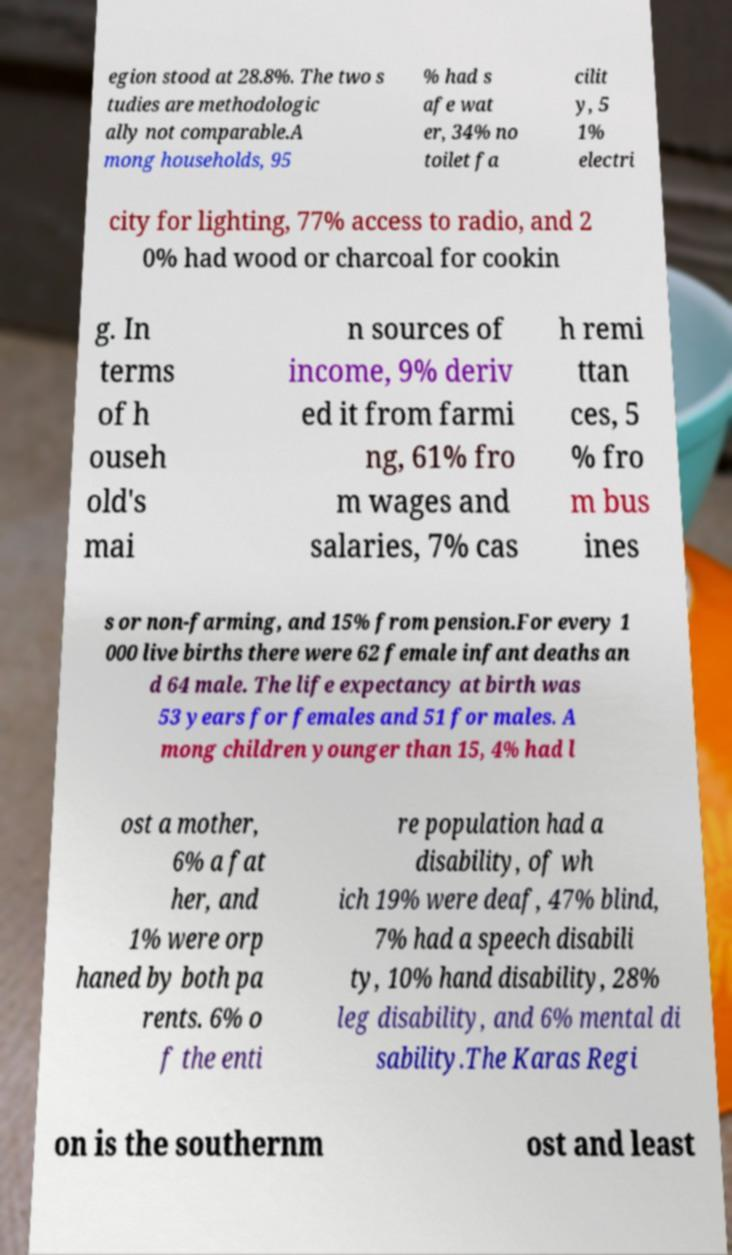Could you assist in decoding the text presented in this image and type it out clearly? egion stood at 28.8%. The two s tudies are methodologic ally not comparable.A mong households, 95 % had s afe wat er, 34% no toilet fa cilit y, 5 1% electri city for lighting, 77% access to radio, and 2 0% had wood or charcoal for cookin g. In terms of h ouseh old's mai n sources of income, 9% deriv ed it from farmi ng, 61% fro m wages and salaries, 7% cas h remi ttan ces, 5 % fro m bus ines s or non-farming, and 15% from pension.For every 1 000 live births there were 62 female infant deaths an d 64 male. The life expectancy at birth was 53 years for females and 51 for males. A mong children younger than 15, 4% had l ost a mother, 6% a fat her, and 1% were orp haned by both pa rents. 6% o f the enti re population had a disability, of wh ich 19% were deaf, 47% blind, 7% had a speech disabili ty, 10% hand disability, 28% leg disability, and 6% mental di sability.The Karas Regi on is the southernm ost and least 